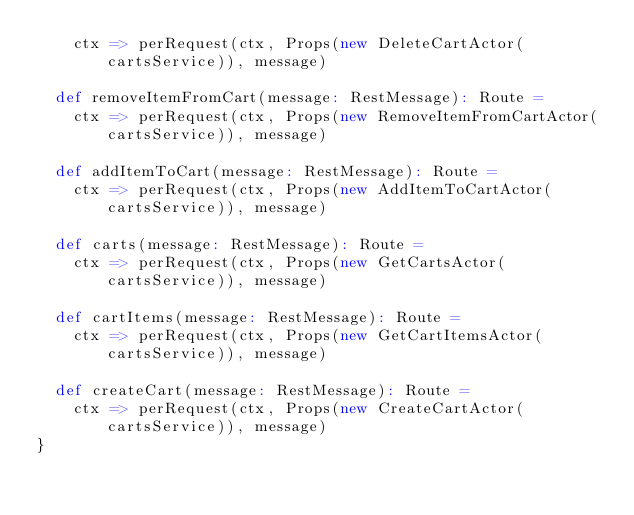Convert code to text. <code><loc_0><loc_0><loc_500><loc_500><_Scala_>    ctx => perRequest(ctx, Props(new DeleteCartActor(cartsService)), message)
  
  def removeItemFromCart(message: RestMessage): Route =
    ctx => perRequest(ctx, Props(new RemoveItemFromCartActor(cartsService)), message)
  
  def addItemToCart(message: RestMessage): Route =
    ctx => perRequest(ctx, Props(new AddItemToCartActor(cartsService)), message)

  def carts(message: RestMessage): Route =
    ctx => perRequest(ctx, Props(new GetCartsActor(cartsService)), message)

  def cartItems(message: RestMessage): Route =
    ctx => perRequest(ctx, Props(new GetCartItemsActor(cartsService)), message)

  def createCart(message: RestMessage): Route =
    ctx => perRequest(ctx, Props(new CreateCartActor(cartsService)), message)
}
</code> 